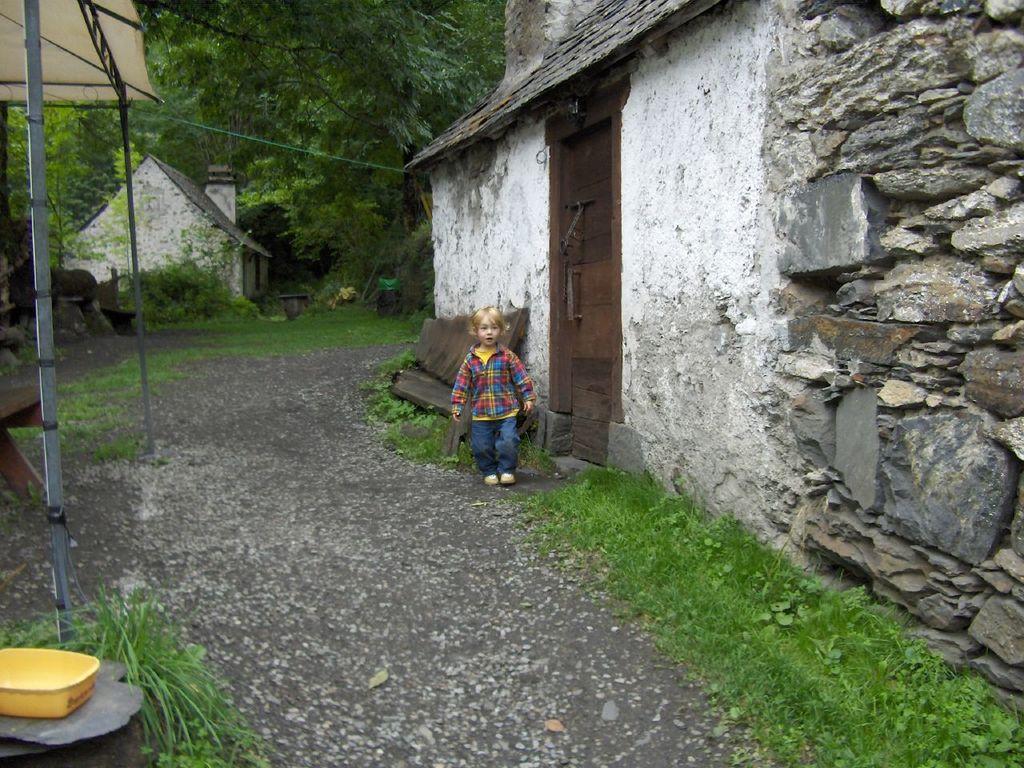Please provide a concise description of this image. In this image, there is an outside view. There is a kid wearing clothes and standing beside the house. There is a tree at the top of the image. There is a tent on the left side of the image. There is a grass in the bottom right of the image. 